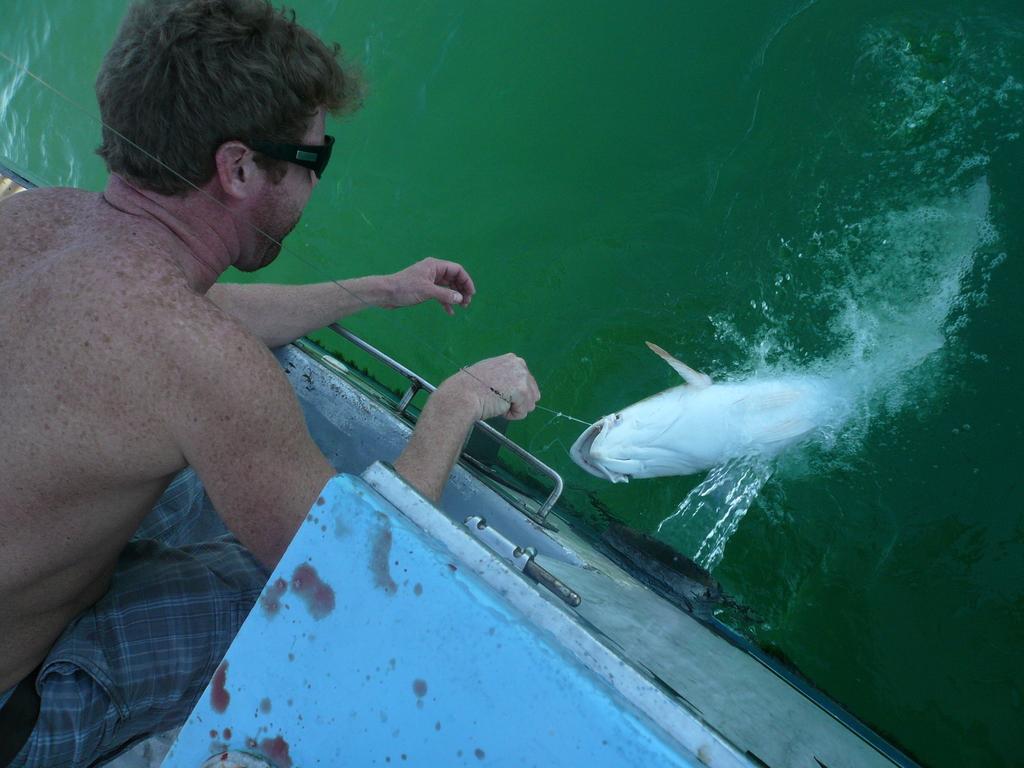How would you summarize this image in a sentence or two? In this image we can see person catching fish in boat. In the background there is water. 